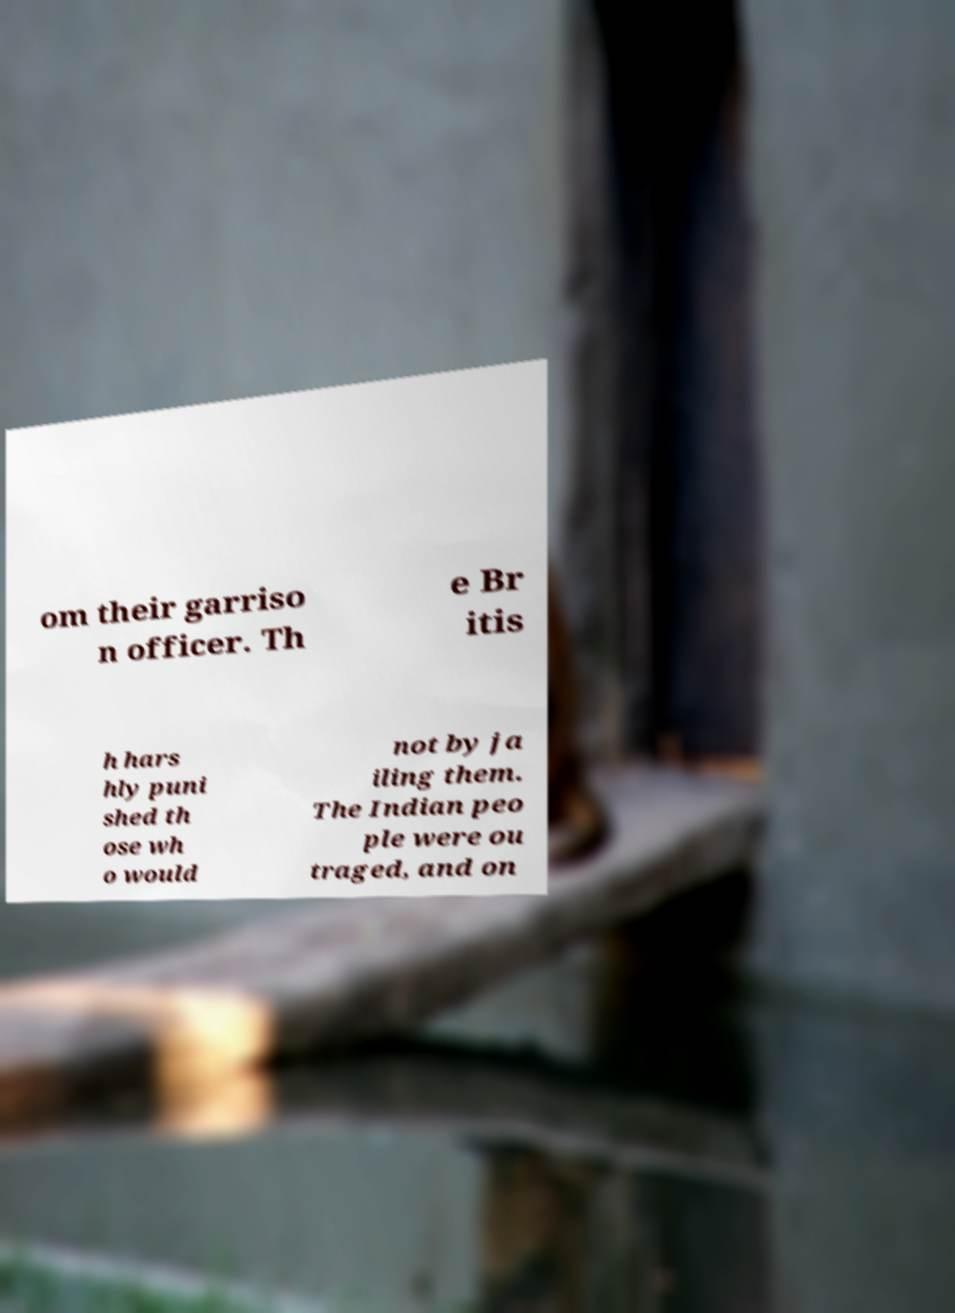Could you assist in decoding the text presented in this image and type it out clearly? om their garriso n officer. Th e Br itis h hars hly puni shed th ose wh o would not by ja iling them. The Indian peo ple were ou traged, and on 